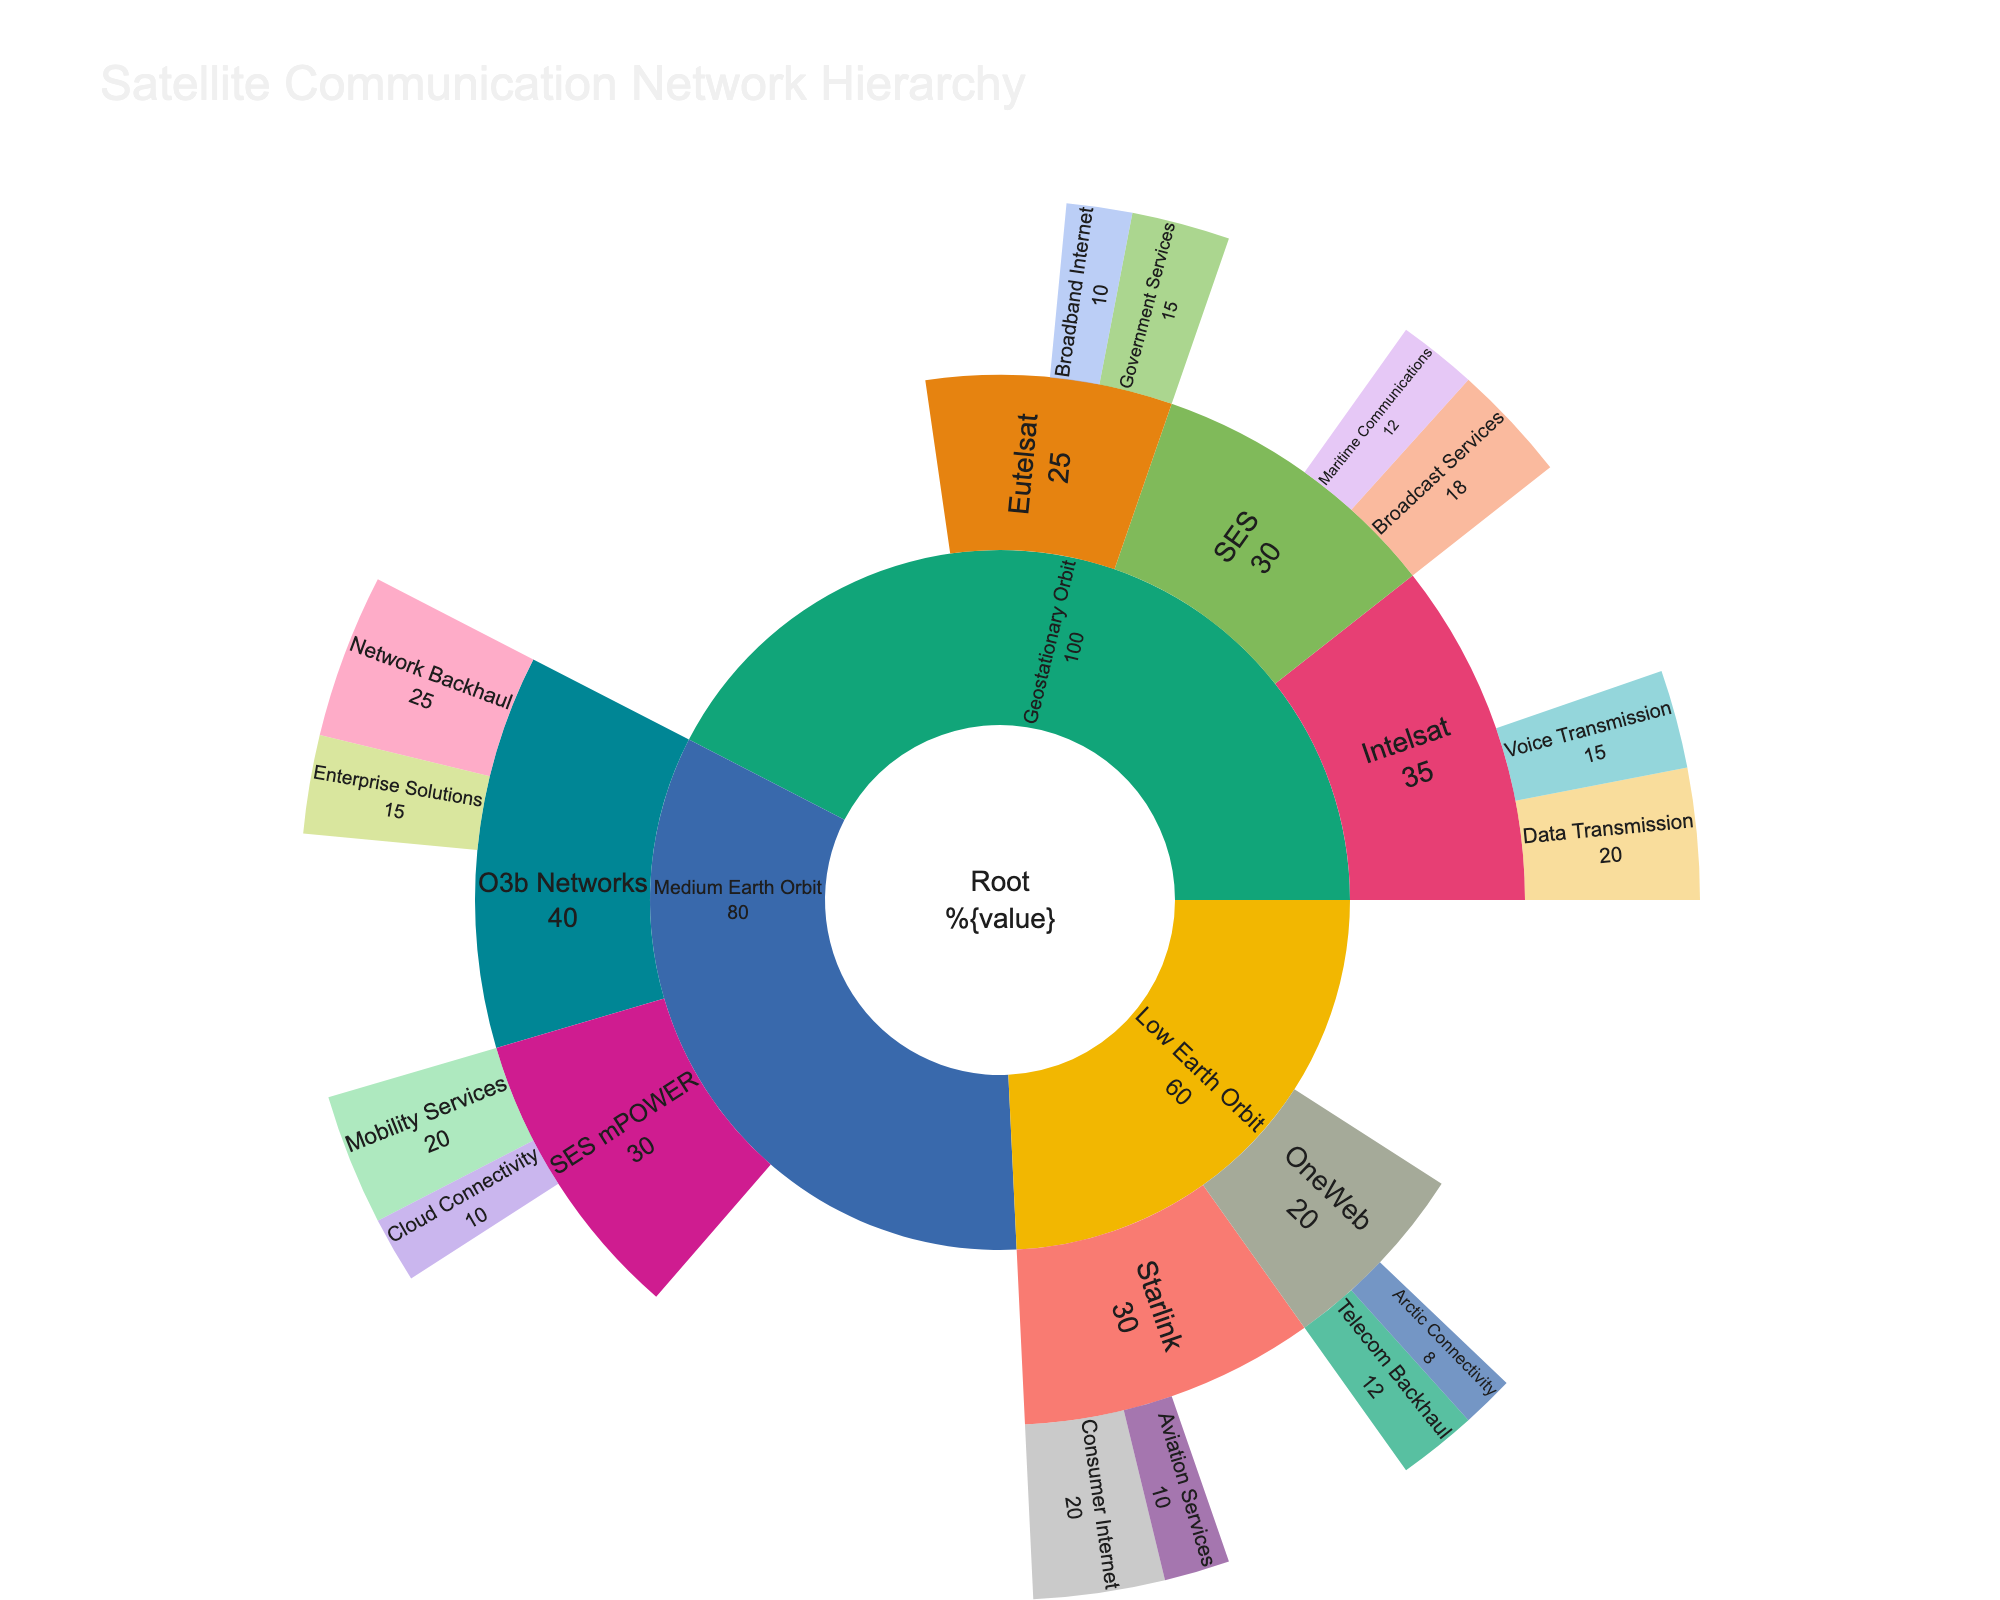What's the title of the figure? The title of the figure can be found at the top of the visual. It helps in understanding the central theme of the plot.
Answer: Satellite Communication Network Hierarchy What are the three primary categories of the satellite network hierarchy? To find this, look at the main branches connected directly to the root. The three primary categories are directly under the “Satellite Network” label.
Answer: Geostationary Orbit, Medium Earth Orbit, Low Earth Orbit Which specific satellite service within Geostationary Orbit has the highest data transmission volume? Find the individual services under "Geostationary Orbit" and compare their data transmission volumes.
Answer: Intelsat How many airtime services are provided by the satellites in the Medium Earth Orbit? Check under "Medium Earth Orbit" and count the services, ignoring the hierarchical structure.
Answer: 2 How much more data does the Geostationary Orbit category transmit compared to the Low Earth Orbit category? Find the corresponding values for Geostationary Orbit and Low Earth Orbit under the sunburst chart. Subtract the value for Low Earth Orbit from that for Geostationary Orbit.
Answer: 40 Compare the total data transmission from the Geostationary Orbit and Medium Earth Orbit categories. Which one transmits more? Sum the values for each category and compare the totals.
Answer: Geostationary Orbit Identify the proportion of total data transmission services under SES in Geo against the entire Geostationary Orbit category. Calculate the total volume for the Geostationary Orbit and find the percentage the SES services contribute.
Answer: 30% Which satellite service in Low Earth Orbit focuses on Telecom Backhaul? Look under Low Earth Orbit and find the service labeled Telecom Backhaul.
Answer: OneWeb What is the combined data transmission volume under Intelsat? Find and sum the values of all services listed under Intelsat.
Answer: 35 Which category has the least number of services: GEO, MEO, or LEO? Count the services under each primary category and determine which has the least.
Answer: Low Earth Orbit 